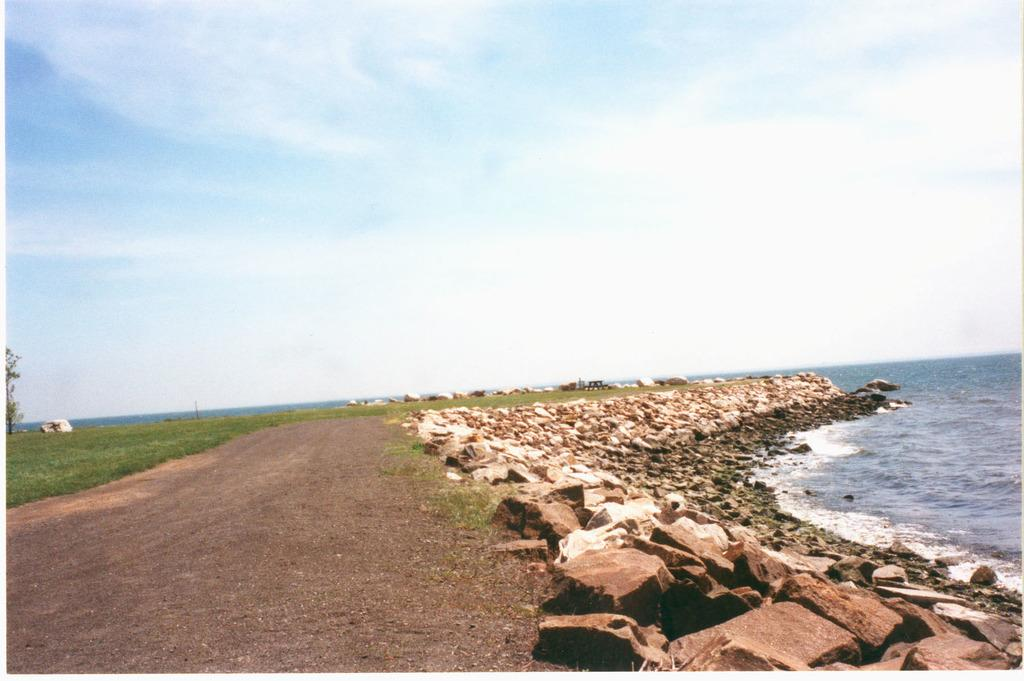What can be seen in the background of the image? The sky is visible in the background of the image. What type of landscape is on the right side of the image? There is a sea on the right side of the image. What type of terrain is on the left side of the image? There is grass on the left side of the image. What other natural element is present on the left side of the image? There is a tree on the left side of the image. What type of material is present in the image? There are stones in the image. What news is being broadcasted on the tree in the image? There is no news being broadcasted on the tree in the image; it is a natural element and not a source of information. 